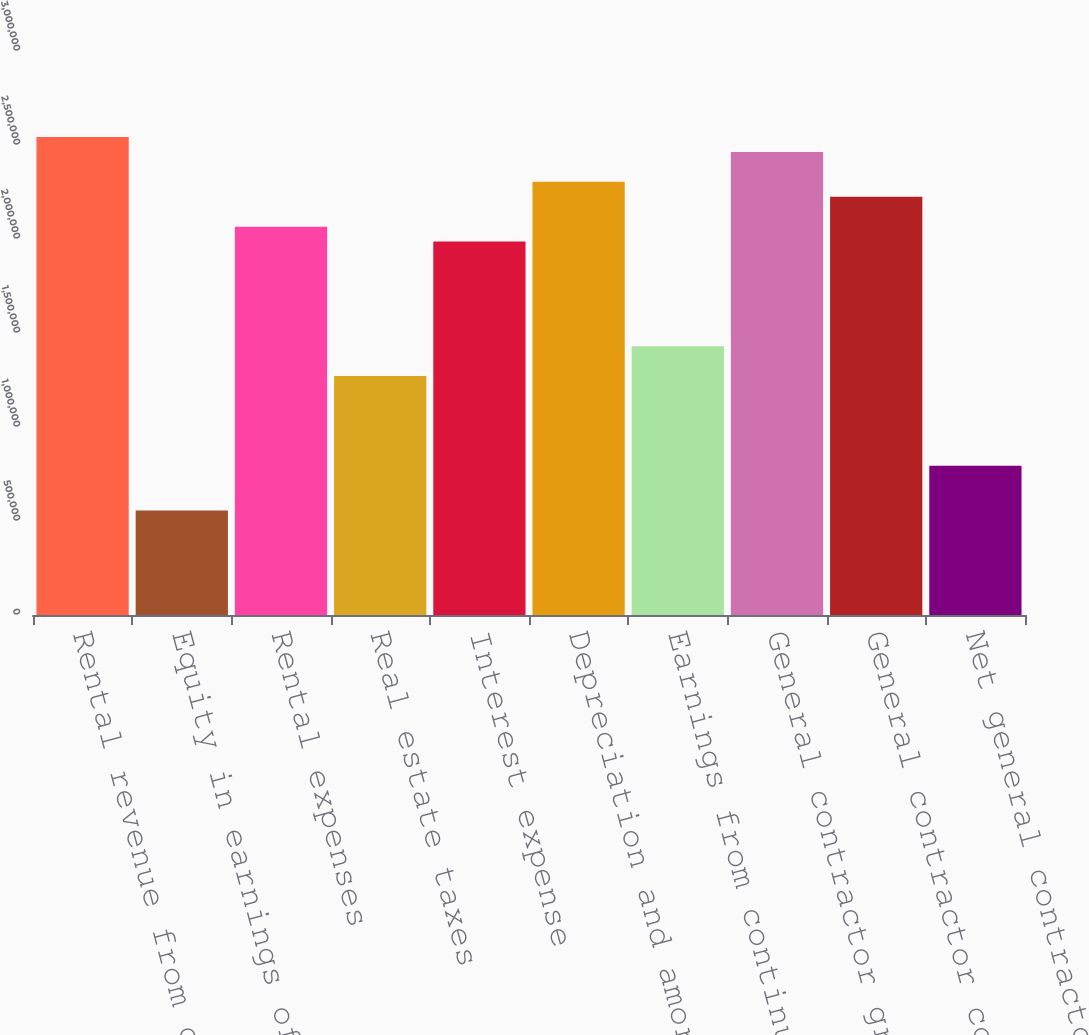Convert chart. <chart><loc_0><loc_0><loc_500><loc_500><bar_chart><fcel>Rental revenue from continuing<fcel>Equity in earnings of<fcel>Rental expenses<fcel>Real estate taxes<fcel>Interest expense<fcel>Depreciation and amortization<fcel>Earnings from continuing<fcel>General contractor gross<fcel>General contractor costs<fcel>Net general contractor revenue<nl><fcel>2.54236e+06<fcel>556142<fcel>2.06567e+06<fcel>1.27118e+06<fcel>1.98622e+06<fcel>2.30401e+06<fcel>1.43008e+06<fcel>2.46291e+06<fcel>2.22457e+06<fcel>794488<nl></chart> 